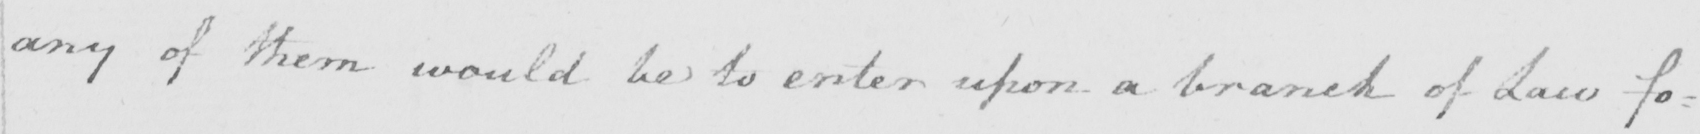Can you read and transcribe this handwriting? any of them would be to enter upon a branch of Law fo : 